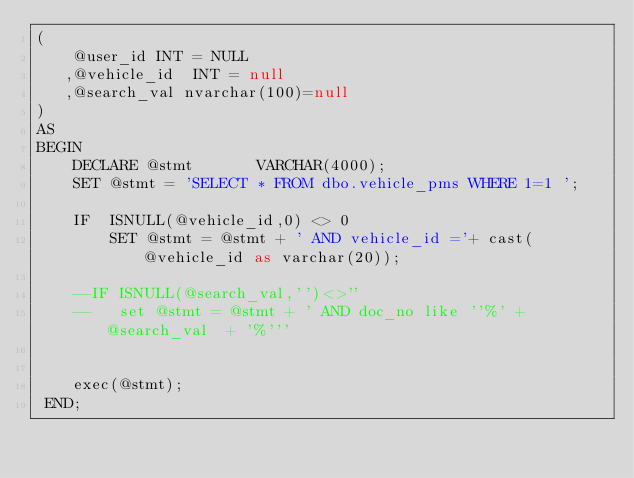<code> <loc_0><loc_0><loc_500><loc_500><_SQL_>(
    @user_id INT = NULL
   ,@vehicle_id  INT = null
   ,@search_val nvarchar(100)=null
)
AS
BEGIN
	DECLARE @stmt		VARCHAR(4000);
 	SET @stmt = 'SELECT * FROM dbo.vehicle_pms WHERE 1=1 ';

	IF  ISNULL(@vehicle_id,0) <> 0
	    SET @stmt = @stmt + ' AND vehicle_id ='+ cast(@vehicle_id as varchar(20));

	--IF ISNULL(@search_val,'')<>''
    --   set @stmt = @stmt + ' AND doc_no like ''%' + @search_val  + '%'''


	exec(@stmt);
 END;</code> 